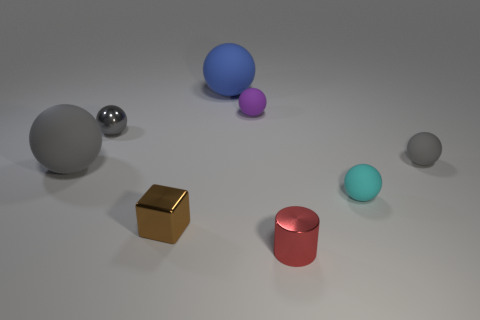What is the size of the red thing on the right side of the small gray ball that is left of the small metal cylinder?
Your response must be concise. Small. What material is the object that is in front of the tiny block?
Keep it short and to the point. Metal. How many objects are gray objects on the left side of the purple rubber ball or large things to the left of the brown block?
Your response must be concise. 2. What is the material of the big blue object that is the same shape as the small gray rubber thing?
Provide a succinct answer. Rubber. There is a tiny matte thing to the left of the small cyan object; does it have the same color as the thing that is on the right side of the small cyan matte thing?
Offer a terse response. No. Are there any purple metal balls that have the same size as the blue sphere?
Your response must be concise. No. What is the sphere that is behind the gray metallic object and in front of the big blue object made of?
Offer a very short reply. Rubber. What number of rubber things are large brown spheres or tiny brown objects?
Provide a succinct answer. 0. What shape is the brown thing that is the same material as the red object?
Offer a terse response. Cube. How many rubber balls are both behind the tiny cyan thing and to the right of the small red thing?
Keep it short and to the point. 1. 